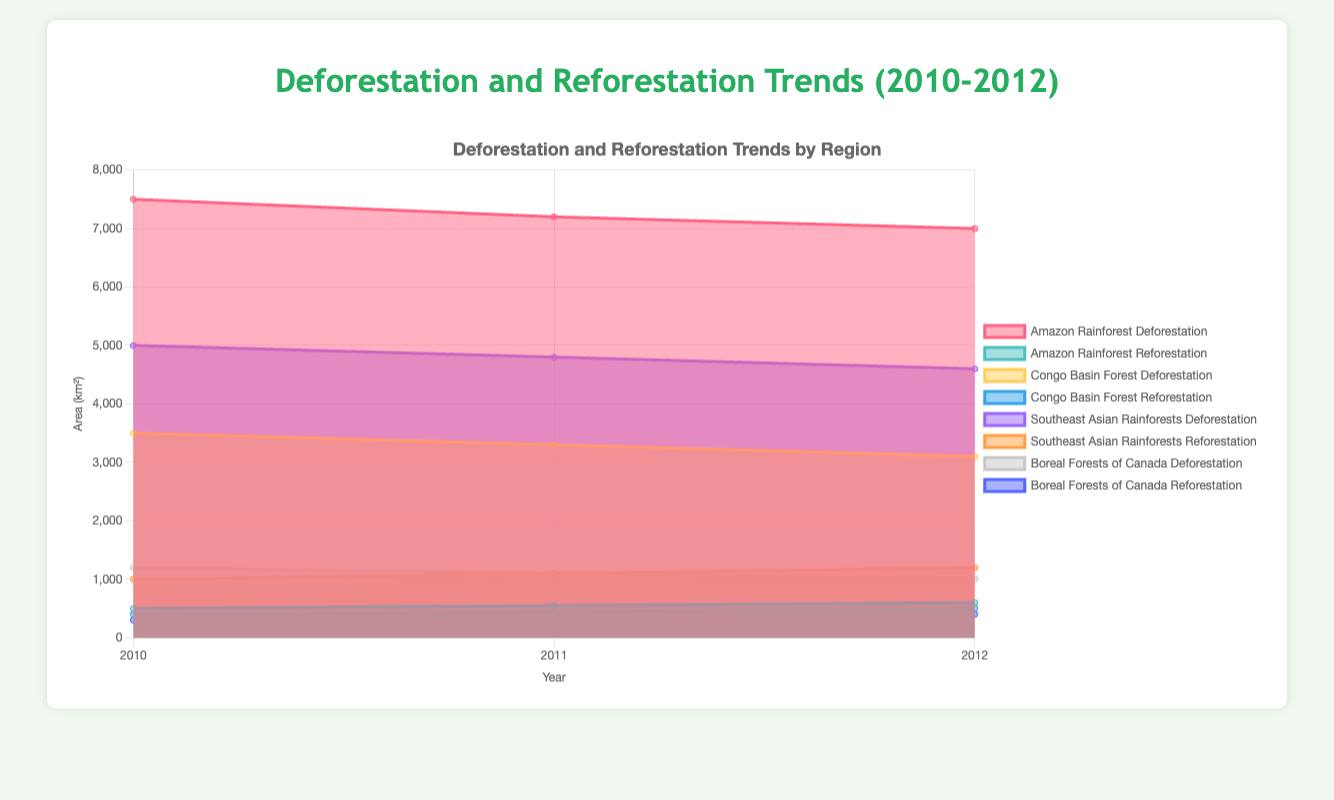What's the title of the chart? The title of the chart is displayed prominently at the top and reads "Deforestation and Reforestation Trends (2010-2012)".
Answer: Deforestation and Reforestation Trends (2010-2012) How does the area representing Amazon Rainforest deforestation change from 2010 to 2012? By examining the filled area under the "Amazon Rainforest Deforestation" dataset, we can see that it starts at 7500 km² in 2010, decreases to 7200 km² in 2011, and further decreases to 7000 km² in 2012.
Answer: Decreases What trend do we observe for reforestation in the Southeast Asian Rainforests from 2010 to 2012? Looking at the "Southeast Asian Rainforests Reforestation" dataset, the filled area increases from 1000 km² in 2010 to 1100 km² in 2011, and then to 1200 km² in 2012.
Answer: Increases Compare the deforestation values between the Congo Basin Forest and the Amazon Rainforest in 2011. The deforestation value for the Congo Basin Forest in 2011 is represented by the filled area at 3300 km², while for the Amazon Rainforest, it is 7200 km². Therefore, the deforestation in the Amazon Rainforest is significantly higher.
Answer: Amazon Rainforest has higher deforestation What’s the difference in deforestation between the Boreal Forests of Canada and the Southeast Asian Rainforests in 2012? In 2012, the deforestation in the Boreal Forests of Canada is 1000 km², while in the Southeast Asian Rainforests, it is 4600 km². The difference is 4600 - 1000 = 3600 km².
Answer: 3600 km² Which region shows the largest increase in reforestation from 2010 to 2012? By comparing the reforestation increases for each region: Amazon Rainforest (100 km²), Congo Basin Forest (100 km²), Southeast Asian Rainforests (200 km²), Boreal Forests of Canada (100 km²). The Southeast Asian Rainforests show the largest increase.
Answer: Southeast Asian Rainforests How does the deforestation in the Amazon Rainforest compare to the Congo Basin Forest in 2010? In 2010, the deforestation in the Amazon Rainforest is 7500 km², while in the Congo Basin Forest it is 3500 km². The Amazon Rainforest experiences more deforestation.
Answer: Amazon Rainforest has more deforestation What is the average deforestation value for the Boreal Forests of Canada over the three years? The deforestation values for the Boreal Forests of Canada are 1200 km², 1100 km², and 1000 km². To find the average: (1200 + 1100 + 1000) / 3 = 1100 km².
Answer: 1100 km² What is the trend in deforestation in the Congo Basin Forest from 2010 to 2012? By inspecting the filled area for "Congo Basin Forest Deforestation," we can see it decreases from 3500 km² in 2010 to 3300 km² in 2011, and then to 3100 km² in 2012.
Answer: Decreases 